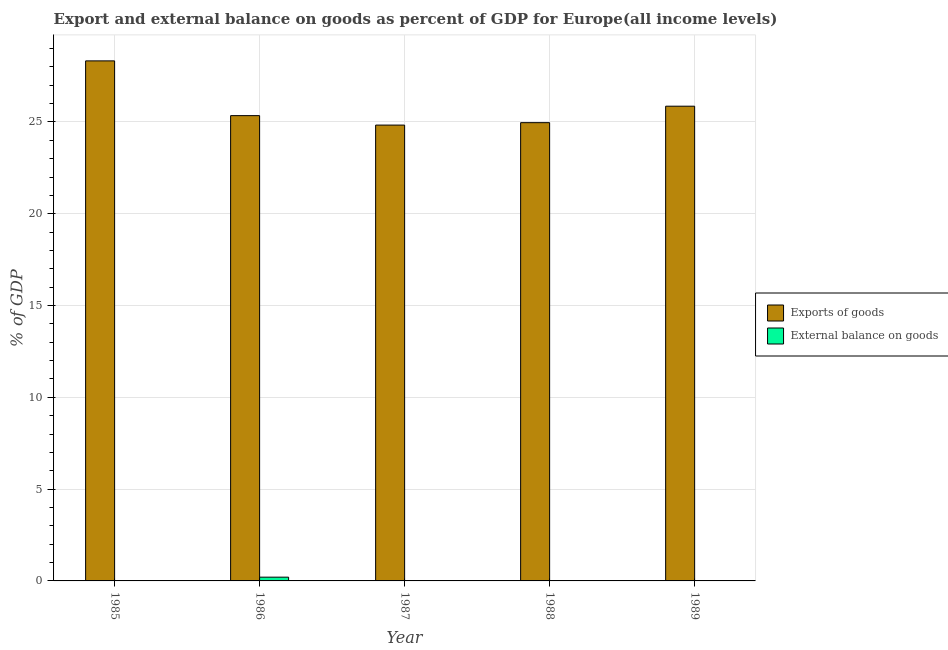How many different coloured bars are there?
Ensure brevity in your answer.  2. Are the number of bars per tick equal to the number of legend labels?
Provide a succinct answer. No. What is the label of the 3rd group of bars from the left?
Keep it short and to the point. 1987. In how many cases, is the number of bars for a given year not equal to the number of legend labels?
Offer a terse response. 3. What is the external balance on goods as percentage of gdp in 1987?
Make the answer very short. 0. Across all years, what is the maximum export of goods as percentage of gdp?
Give a very brief answer. 28.33. In which year was the export of goods as percentage of gdp maximum?
Your answer should be compact. 1985. What is the total export of goods as percentage of gdp in the graph?
Provide a short and direct response. 129.32. What is the difference between the export of goods as percentage of gdp in 1985 and that in 1987?
Your response must be concise. 3.5. What is the difference between the external balance on goods as percentage of gdp in 1986 and the export of goods as percentage of gdp in 1985?
Offer a very short reply. 0.2. What is the average external balance on goods as percentage of gdp per year?
Offer a terse response. 0.04. In the year 1987, what is the difference between the export of goods as percentage of gdp and external balance on goods as percentage of gdp?
Keep it short and to the point. 0. What is the ratio of the export of goods as percentage of gdp in 1987 to that in 1988?
Offer a very short reply. 0.99. What is the difference between the highest and the second highest export of goods as percentage of gdp?
Your answer should be compact. 2.47. What is the difference between the highest and the lowest external balance on goods as percentage of gdp?
Give a very brief answer. 0.2. In how many years, is the export of goods as percentage of gdp greater than the average export of goods as percentage of gdp taken over all years?
Your answer should be very brief. 1. Is the sum of the export of goods as percentage of gdp in 1986 and 1987 greater than the maximum external balance on goods as percentage of gdp across all years?
Your answer should be very brief. Yes. How many bars are there?
Keep it short and to the point. 7. Are all the bars in the graph horizontal?
Give a very brief answer. No. What is the difference between two consecutive major ticks on the Y-axis?
Offer a very short reply. 5. Where does the legend appear in the graph?
Your answer should be very brief. Center right. How many legend labels are there?
Provide a succinct answer. 2. What is the title of the graph?
Keep it short and to the point. Export and external balance on goods as percent of GDP for Europe(all income levels). Does "Male population" appear as one of the legend labels in the graph?
Keep it short and to the point. No. What is the label or title of the Y-axis?
Provide a succinct answer. % of GDP. What is the % of GDP in Exports of goods in 1985?
Your response must be concise. 28.33. What is the % of GDP in External balance on goods in 1985?
Make the answer very short. 0. What is the % of GDP in Exports of goods in 1986?
Provide a succinct answer. 25.35. What is the % of GDP of External balance on goods in 1986?
Your answer should be compact. 0.2. What is the % of GDP of Exports of goods in 1987?
Your response must be concise. 24.83. What is the % of GDP of External balance on goods in 1987?
Your answer should be compact. 0. What is the % of GDP in Exports of goods in 1988?
Make the answer very short. 24.96. What is the % of GDP in External balance on goods in 1988?
Offer a very short reply. 0. What is the % of GDP in Exports of goods in 1989?
Your answer should be compact. 25.86. Across all years, what is the maximum % of GDP in Exports of goods?
Your response must be concise. 28.33. Across all years, what is the maximum % of GDP of External balance on goods?
Provide a short and direct response. 0.2. Across all years, what is the minimum % of GDP of Exports of goods?
Your answer should be compact. 24.83. What is the total % of GDP of Exports of goods in the graph?
Give a very brief answer. 129.32. What is the total % of GDP of External balance on goods in the graph?
Offer a terse response. 0.21. What is the difference between the % of GDP of Exports of goods in 1985 and that in 1986?
Your response must be concise. 2.98. What is the difference between the % of GDP in External balance on goods in 1985 and that in 1986?
Your answer should be very brief. -0.2. What is the difference between the % of GDP in Exports of goods in 1985 and that in 1987?
Your answer should be compact. 3.5. What is the difference between the % of GDP in Exports of goods in 1985 and that in 1988?
Your answer should be compact. 3.37. What is the difference between the % of GDP in Exports of goods in 1985 and that in 1989?
Provide a short and direct response. 2.47. What is the difference between the % of GDP in Exports of goods in 1986 and that in 1987?
Offer a terse response. 0.51. What is the difference between the % of GDP in Exports of goods in 1986 and that in 1988?
Ensure brevity in your answer.  0.38. What is the difference between the % of GDP of Exports of goods in 1986 and that in 1989?
Your answer should be very brief. -0.51. What is the difference between the % of GDP in Exports of goods in 1987 and that in 1988?
Give a very brief answer. -0.13. What is the difference between the % of GDP of Exports of goods in 1987 and that in 1989?
Make the answer very short. -1.03. What is the difference between the % of GDP of Exports of goods in 1988 and that in 1989?
Your answer should be compact. -0.9. What is the difference between the % of GDP in Exports of goods in 1985 and the % of GDP in External balance on goods in 1986?
Your answer should be very brief. 28.12. What is the average % of GDP in Exports of goods per year?
Your answer should be compact. 25.86. What is the average % of GDP in External balance on goods per year?
Offer a terse response. 0.04. In the year 1985, what is the difference between the % of GDP in Exports of goods and % of GDP in External balance on goods?
Make the answer very short. 28.32. In the year 1986, what is the difference between the % of GDP of Exports of goods and % of GDP of External balance on goods?
Offer a very short reply. 25.14. What is the ratio of the % of GDP in Exports of goods in 1985 to that in 1986?
Ensure brevity in your answer.  1.12. What is the ratio of the % of GDP in External balance on goods in 1985 to that in 1986?
Your response must be concise. 0.02. What is the ratio of the % of GDP of Exports of goods in 1985 to that in 1987?
Your answer should be very brief. 1.14. What is the ratio of the % of GDP in Exports of goods in 1985 to that in 1988?
Provide a succinct answer. 1.13. What is the ratio of the % of GDP of Exports of goods in 1985 to that in 1989?
Keep it short and to the point. 1.1. What is the ratio of the % of GDP of Exports of goods in 1986 to that in 1987?
Your answer should be very brief. 1.02. What is the ratio of the % of GDP of Exports of goods in 1986 to that in 1988?
Ensure brevity in your answer.  1.02. What is the ratio of the % of GDP in Exports of goods in 1986 to that in 1989?
Your answer should be compact. 0.98. What is the ratio of the % of GDP of Exports of goods in 1987 to that in 1988?
Offer a terse response. 0.99. What is the ratio of the % of GDP of Exports of goods in 1987 to that in 1989?
Ensure brevity in your answer.  0.96. What is the ratio of the % of GDP in Exports of goods in 1988 to that in 1989?
Your response must be concise. 0.97. What is the difference between the highest and the second highest % of GDP of Exports of goods?
Keep it short and to the point. 2.47. What is the difference between the highest and the lowest % of GDP in Exports of goods?
Your response must be concise. 3.5. What is the difference between the highest and the lowest % of GDP of External balance on goods?
Your answer should be compact. 0.2. 